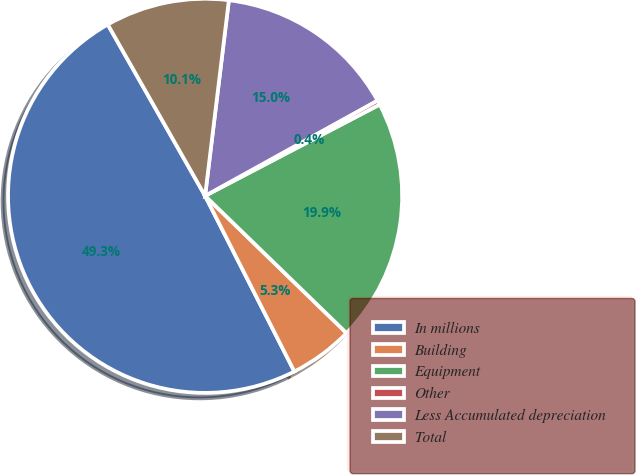<chart> <loc_0><loc_0><loc_500><loc_500><pie_chart><fcel>In millions<fcel>Building<fcel>Equipment<fcel>Other<fcel>Less Accumulated depreciation<fcel>Total<nl><fcel>49.27%<fcel>5.26%<fcel>19.93%<fcel>0.37%<fcel>15.04%<fcel>10.15%<nl></chart> 